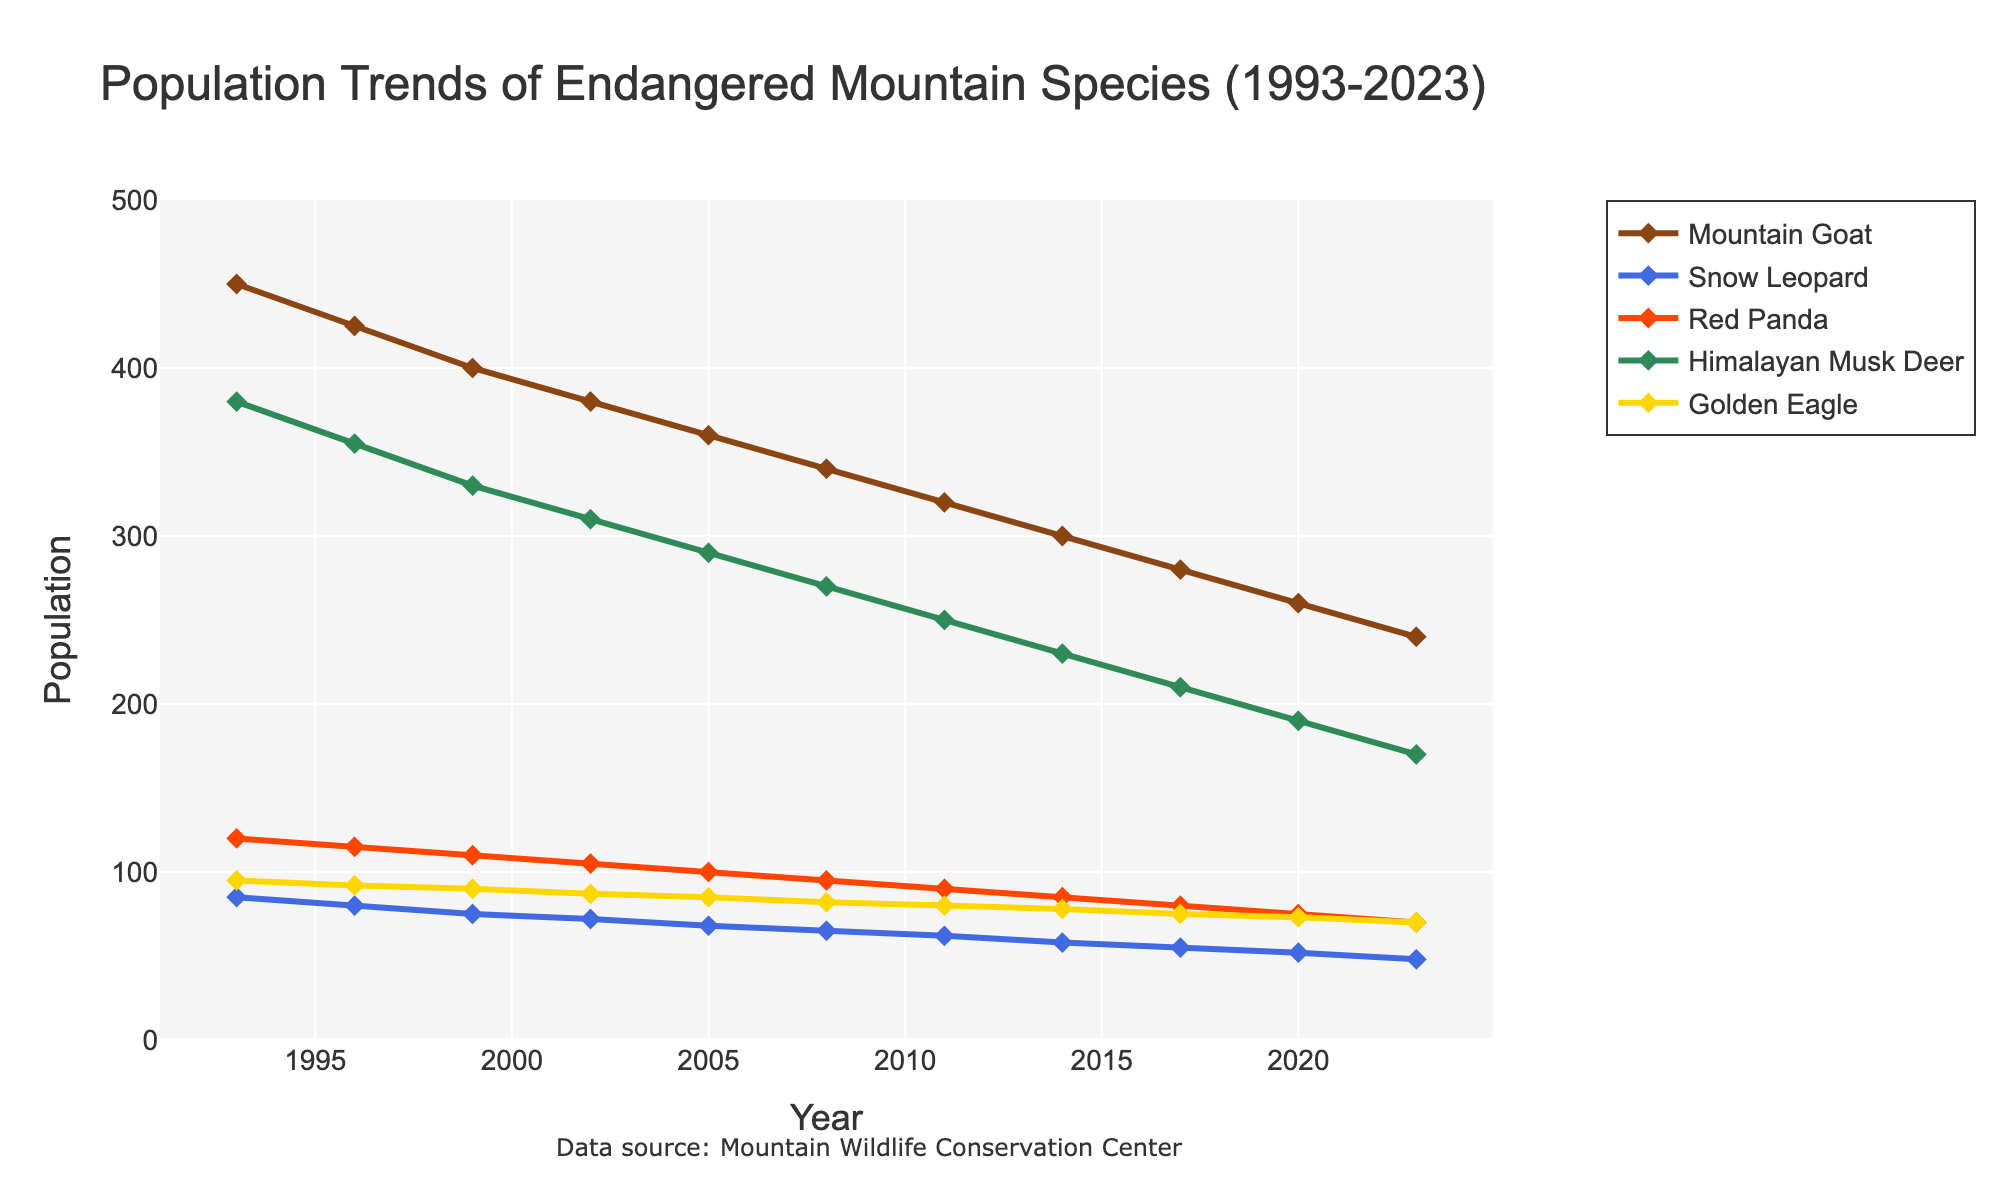what is the overall trend observed in the population of mountain goats from 1993 to 2023? The population of mountain goats is shown to decrease over the 30-year period from 1993 to 2023. By observing the line for mountain goats (brown), it starts high around 450 individuals in 1993 and progressively declines to around 240 in 2023.
Answer: Decline How much has the population of snow leopards decreased from 1993 to 2023? To find the decrease in the population, subtract the population in 2023 from the population in 1993. Snow leopards' population was 85 in 1993 and decreased to 48 in 2023. Hence, the decrease is 85 - 48.
Answer: 37 Which endangered species has seen the least decline in population over the 30-year period? To determine this, observe each species' population decline by comparing their initial (1993) and final (2023) populations. The Golden Eagle has decreased from 95 to 70, which is the smallest decline among all species.
Answer: Golden Eagle Across which years did the Himalayan Musk Deer's population show the sharpest decline? Look at the slope of the line representing the Himalayan Musk Deer. The sharpest decline appears from 1993 to 1996 where it drops from 380 to 355.  This decline of 25 is the largest in a three-year span.
Answer: 1993 to 1996 What's the combined population of Red Pandas and Mountain Goats in 2008? Add the population of Red Pandas and Mountain Goats for the year 2008. The populations are 95 (Red Pandas) and 340 (Mountain Goats). Therefore, the combined population is 95 + 340.
Answer: 435 Compare the population trends of Mountain Goats and Red Pandas. Which species shows a more rapid reduction in population? By observing the lines, the Mountain Goats show a steeper and more rapid decline from 1993 (450) to 2023 (240), compared to Red Pandas which go from 120 to 70 over the same period. The Mountain Goats' population declines more rapidly.
Answer: Mountain Goats In what year did the population of Golden Eagles converge with the population of Snow Leopards? Find where the lines for Golden Eagles (yellow) and Snow Leopards (blue) cross. The populations converge around 2023.
Answer: 2023 What is the average population of the Golden Eagle over the 30-year period? Sum the populations of the Golden Eagle at all the time points given, then divide by the number of time points. (95+92+90+87+85+82+80+78+75+73+70)/11 = 82.
Answer: 82 By how much did the population of the Himalayan Musk Deer drop between 2014 and 2023? Subtract the population in 2023 from the population in 2014 for the Himalayan Musk Deer. Therefore, 230 - 170 = 60.
Answer: 60 During which three-year period did the Red Panda population drop the most? By examining the slope of the Red Panda's line, the largest drop occurs between 2017 and 2020, where the population falls from 80 to 75. This is a relatively small decline over three years compared to others of five units.
Answer: 2017 to 2020 